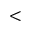Convert formula to latex. <formula><loc_0><loc_0><loc_500><loc_500><</formula> 